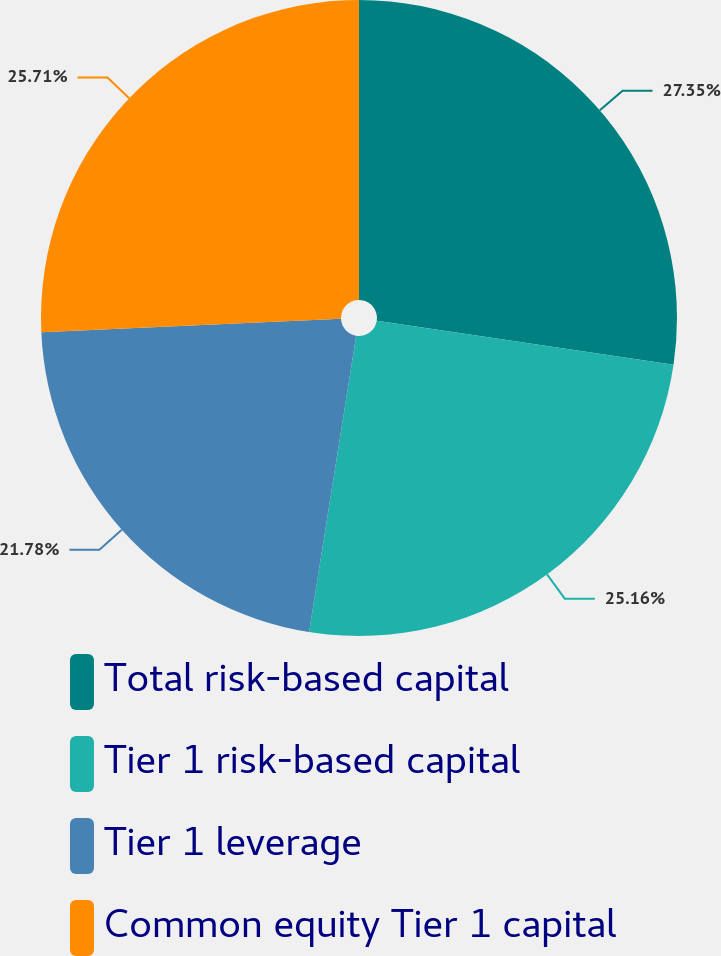Convert chart to OTSL. <chart><loc_0><loc_0><loc_500><loc_500><pie_chart><fcel>Total risk-based capital<fcel>Tier 1 risk-based capital<fcel>Tier 1 leverage<fcel>Common equity Tier 1 capital<nl><fcel>27.35%<fcel>25.16%<fcel>21.78%<fcel>25.71%<nl></chart> 